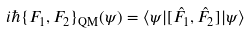<formula> <loc_0><loc_0><loc_500><loc_500>i \hbar { \{ } F _ { 1 } , F _ { 2 } \} _ { \text {QM} } ( \psi ) = \langle \psi | [ \hat { F _ { 1 } } , \hat { F _ { 2 } } ] | \psi \rangle</formula> 